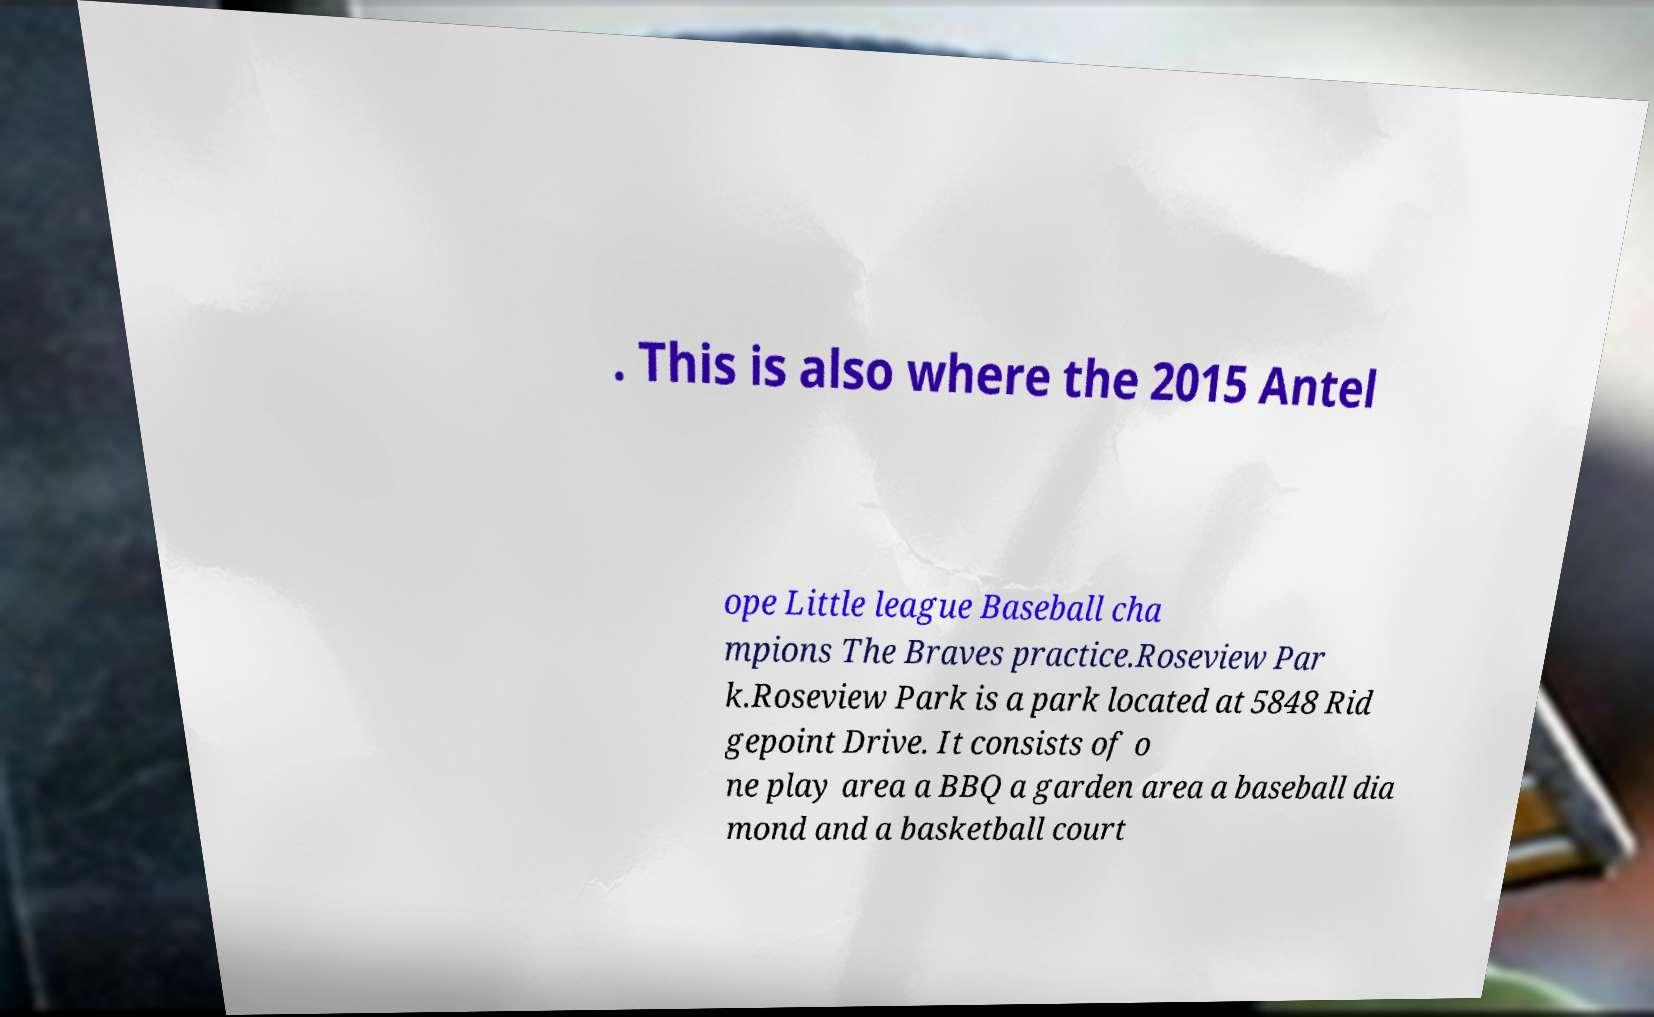I need the written content from this picture converted into text. Can you do that? . This is also where the 2015 Antel ope Little league Baseball cha mpions The Braves practice.Roseview Par k.Roseview Park is a park located at 5848 Rid gepoint Drive. It consists of o ne play area a BBQ a garden area a baseball dia mond and a basketball court 